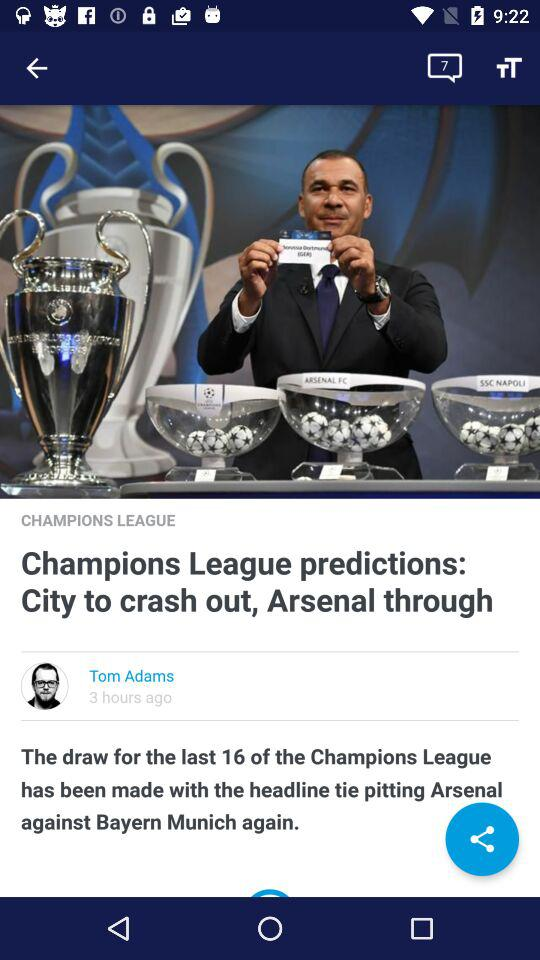How many hours ago was the article posted? The article was posted three hours ago. 